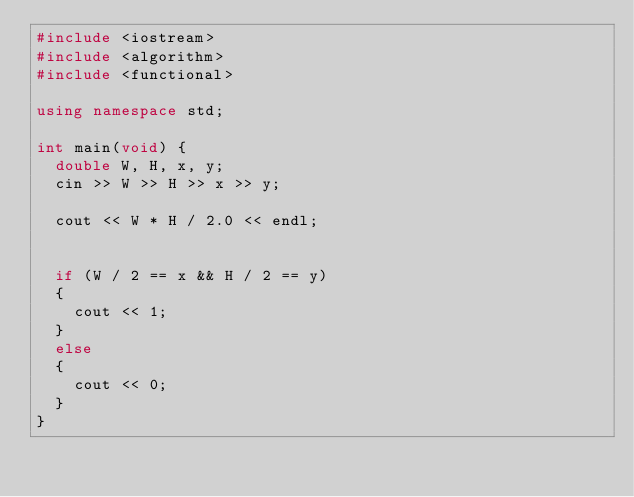<code> <loc_0><loc_0><loc_500><loc_500><_C++_>#include <iostream>
#include <algorithm>
#include <functional>

using namespace std;

int main(void) {
	double W, H, x, y;
	cin >> W >> H >> x >> y;

	cout << W * H / 2.0 << endl;


	if (W / 2 == x && H / 2 == y)
	{
		cout << 1;
	}
	else
	{
		cout << 0;
	}
}</code> 